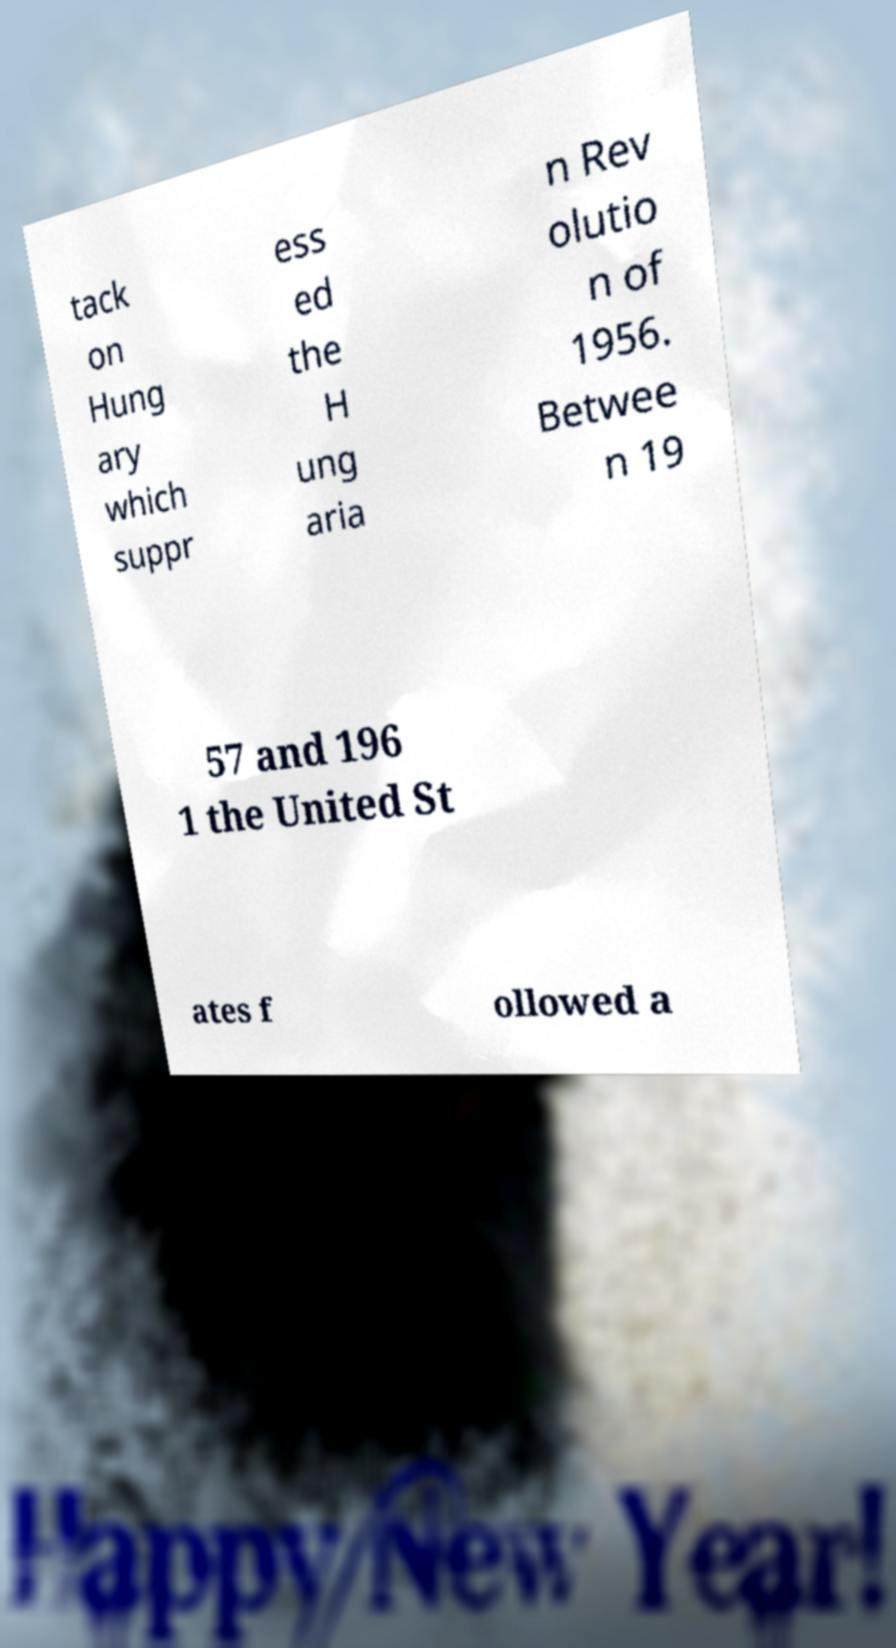Could you assist in decoding the text presented in this image and type it out clearly? tack on Hung ary which suppr ess ed the H ung aria n Rev olutio n of 1956. Betwee n 19 57 and 196 1 the United St ates f ollowed a 